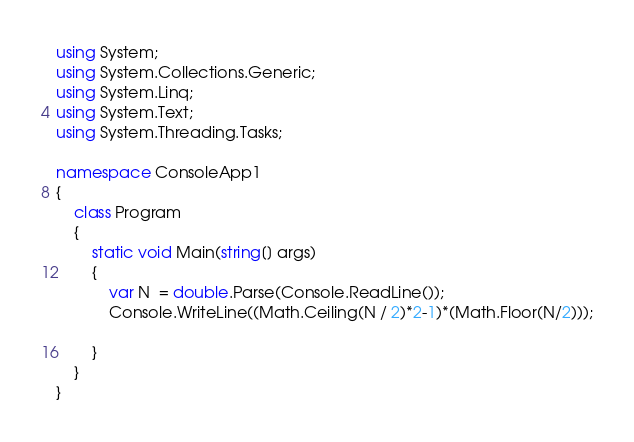Convert code to text. <code><loc_0><loc_0><loc_500><loc_500><_C#_>using System;
using System.Collections.Generic;
using System.Linq;
using System.Text;
using System.Threading.Tasks;

namespace ConsoleApp1
{
    class Program
    {
        static void Main(string[] args)
        {
            var N  = double.Parse(Console.ReadLine());
            Console.WriteLine((Math.Ceiling(N / 2)*2-1)*(Math.Floor(N/2)));

        }
    }
}
</code> 